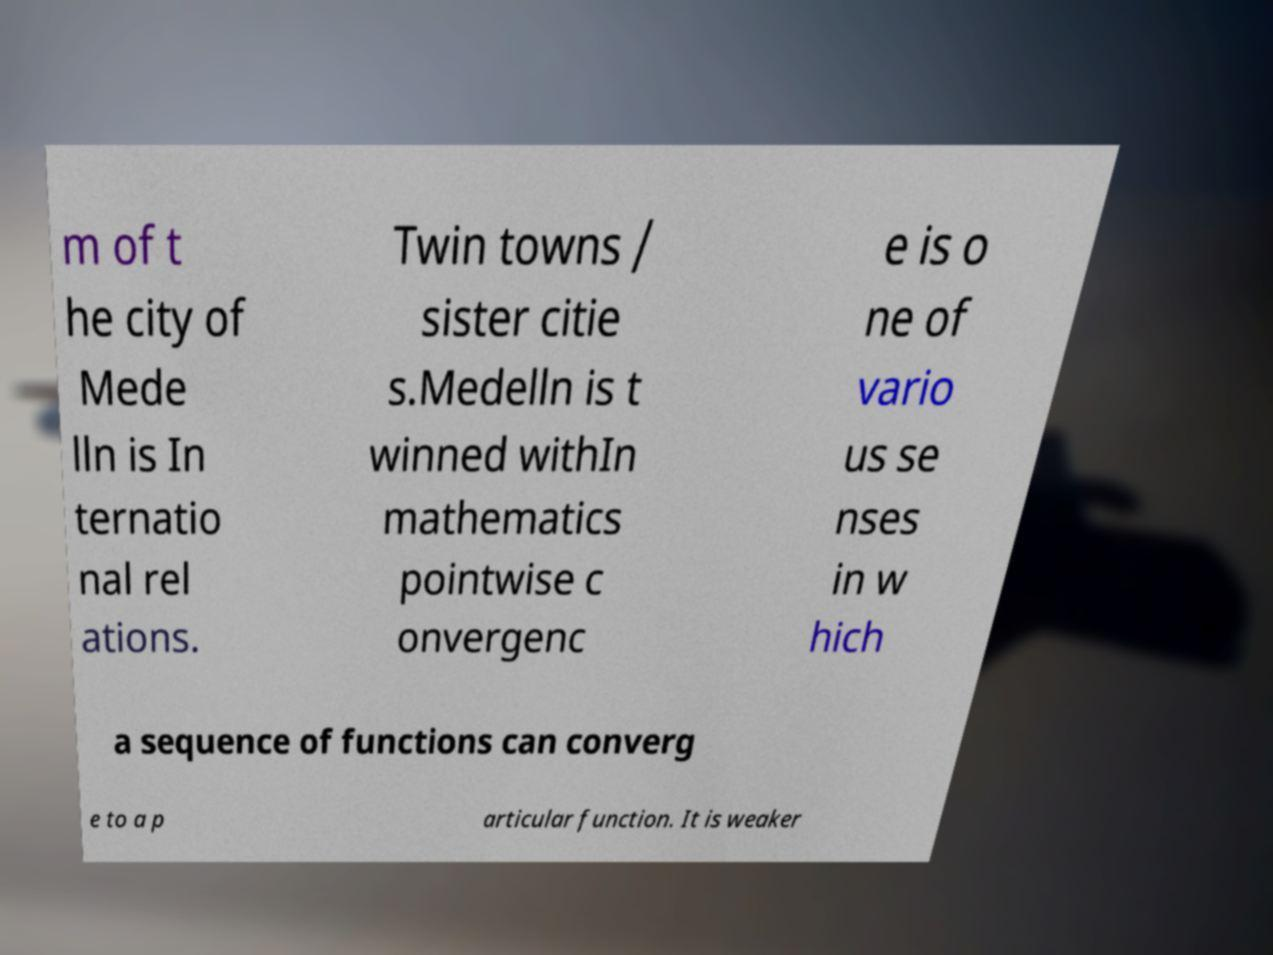Could you assist in decoding the text presented in this image and type it out clearly? m of t he city of Mede lln is In ternatio nal rel ations. Twin towns / sister citie s.Medelln is t winned withIn mathematics pointwise c onvergenc e is o ne of vario us se nses in w hich a sequence of functions can converg e to a p articular function. It is weaker 